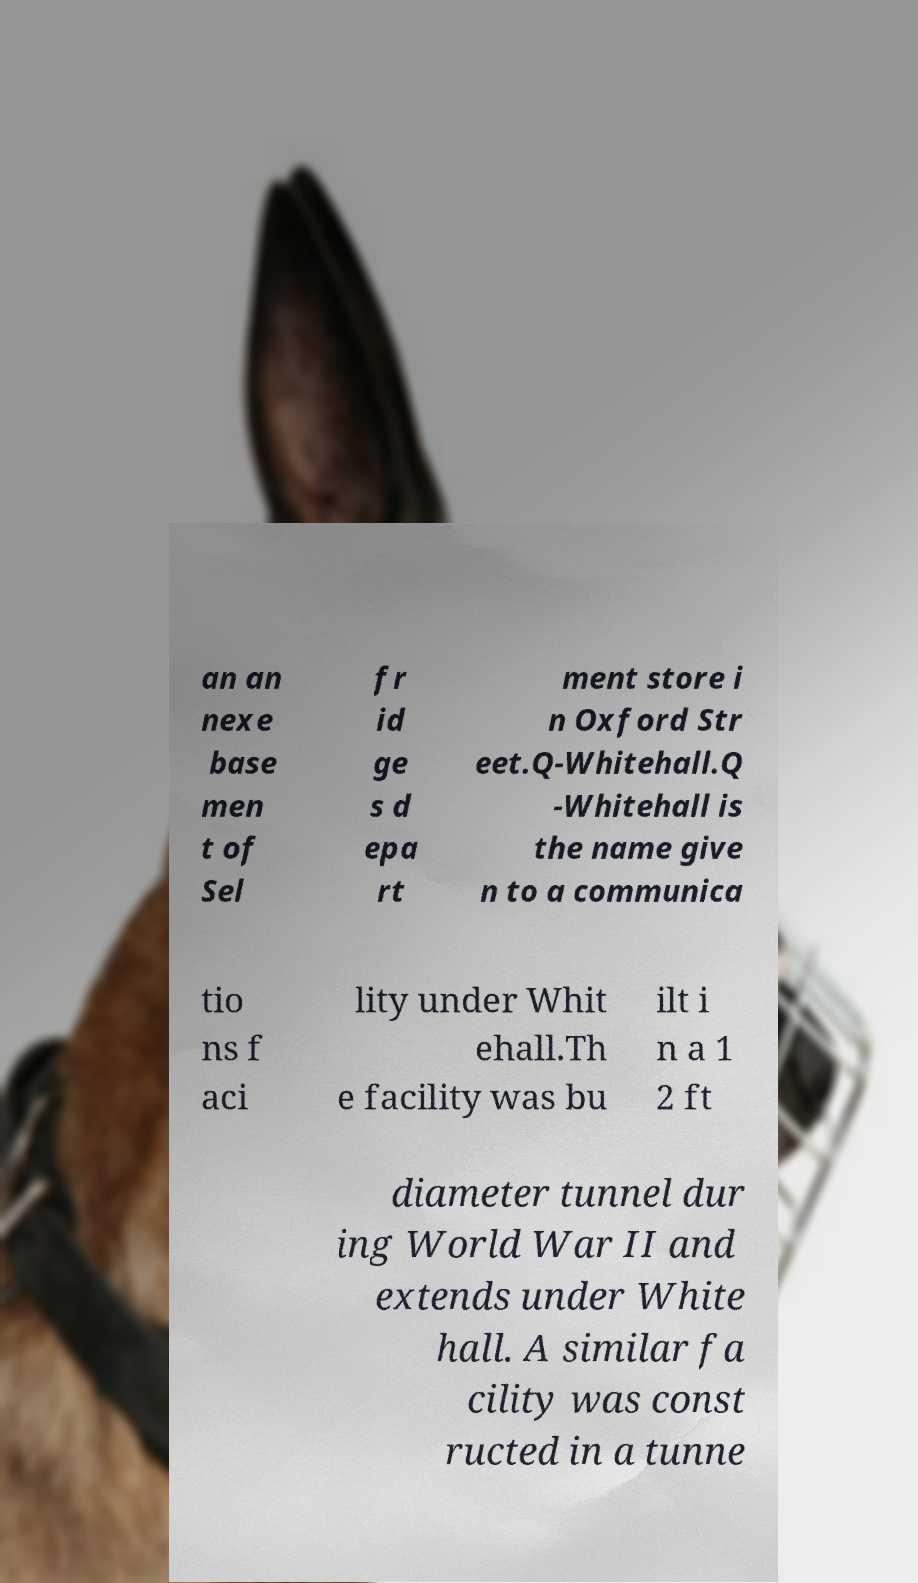Could you assist in decoding the text presented in this image and type it out clearly? an an nexe base men t of Sel fr id ge s d epa rt ment store i n Oxford Str eet.Q-Whitehall.Q -Whitehall is the name give n to a communica tio ns f aci lity under Whit ehall.Th e facility was bu ilt i n a 1 2 ft diameter tunnel dur ing World War II and extends under White hall. A similar fa cility was const ructed in a tunne 